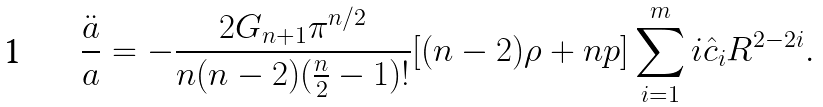Convert formula to latex. <formula><loc_0><loc_0><loc_500><loc_500>\frac { \ddot { a } } { a } = - \frac { 2 G _ { n + 1 } \pi ^ { n / 2 } } { n ( n - 2 ) ( \frac { n } { 2 } - 1 ) ! } [ ( n - 2 ) \rho + n p ] \sum _ { i = 1 } ^ { m } i { \hat { c } _ { i } } R ^ { 2 - 2 i } .</formula> 